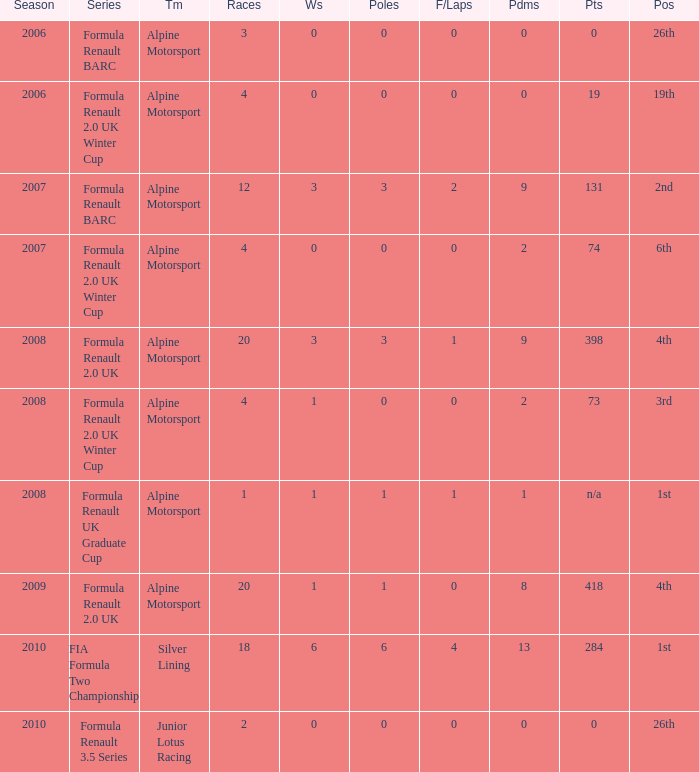What races achieved 0 f/laps and 1 pole position? 20.0. Write the full table. {'header': ['Season', 'Series', 'Tm', 'Races', 'Ws', 'Poles', 'F/Laps', 'Pdms', 'Pts', 'Pos'], 'rows': [['2006', 'Formula Renault BARC', 'Alpine Motorsport', '3', '0', '0', '0', '0', '0', '26th'], ['2006', 'Formula Renault 2.0 UK Winter Cup', 'Alpine Motorsport', '4', '0', '0', '0', '0', '19', '19th'], ['2007', 'Formula Renault BARC', 'Alpine Motorsport', '12', '3', '3', '2', '9', '131', '2nd'], ['2007', 'Formula Renault 2.0 UK Winter Cup', 'Alpine Motorsport', '4', '0', '0', '0', '2', '74', '6th'], ['2008', 'Formula Renault 2.0 UK', 'Alpine Motorsport', '20', '3', '3', '1', '9', '398', '4th'], ['2008', 'Formula Renault 2.0 UK Winter Cup', 'Alpine Motorsport', '4', '1', '0', '0', '2', '73', '3rd'], ['2008', 'Formula Renault UK Graduate Cup', 'Alpine Motorsport', '1', '1', '1', '1', '1', 'n/a', '1st'], ['2009', 'Formula Renault 2.0 UK', 'Alpine Motorsport', '20', '1', '1', '0', '8', '418', '4th'], ['2010', 'FIA Formula Two Championship', 'Silver Lining', '18', '6', '6', '4', '13', '284', '1st'], ['2010', 'Formula Renault 3.5 Series', 'Junior Lotus Racing', '2', '0', '0', '0', '0', '0', '26th']]} 